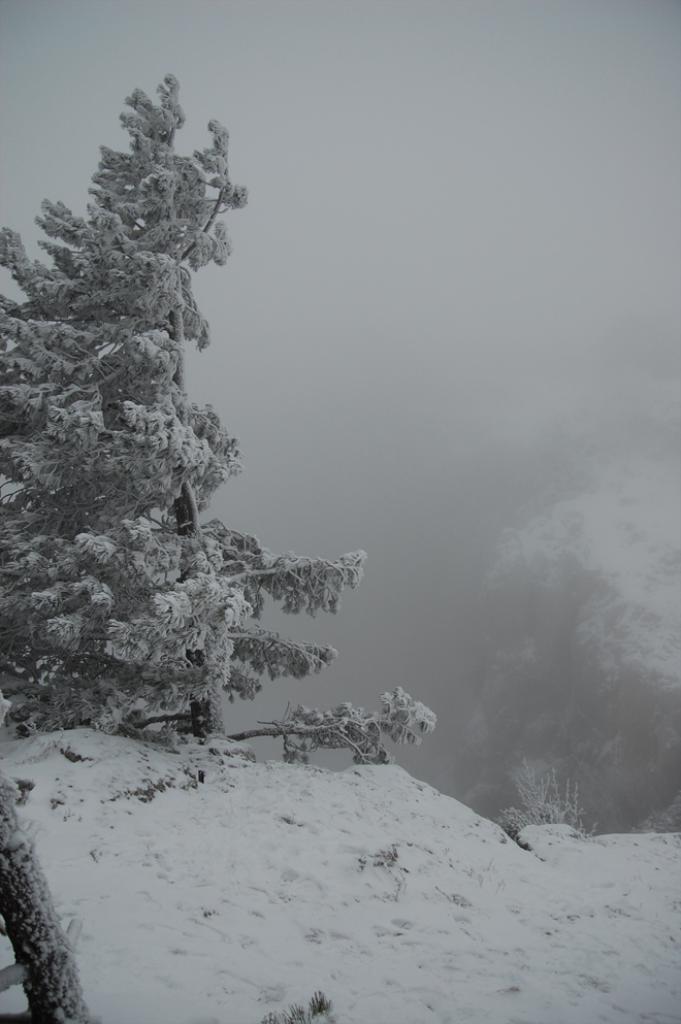Please provide a concise description of this image. In this image I can see mountains, trees, fog and the sky. This image is taken may be near the mountains. 